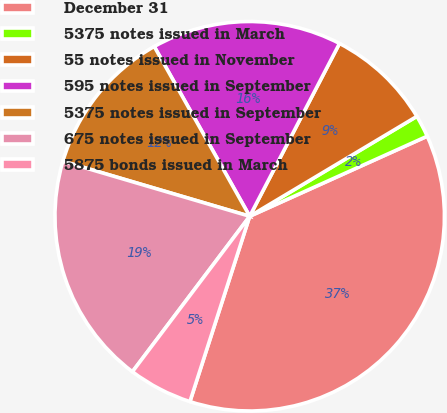Convert chart. <chart><loc_0><loc_0><loc_500><loc_500><pie_chart><fcel>December 31<fcel>5375 notes issued in March<fcel>55 notes issued in November<fcel>595 notes issued in September<fcel>5375 notes issued in September<fcel>675 notes issued in September<fcel>5875 bonds issued in March<nl><fcel>36.71%<fcel>1.83%<fcel>8.8%<fcel>15.78%<fcel>12.29%<fcel>19.27%<fcel>5.32%<nl></chart> 